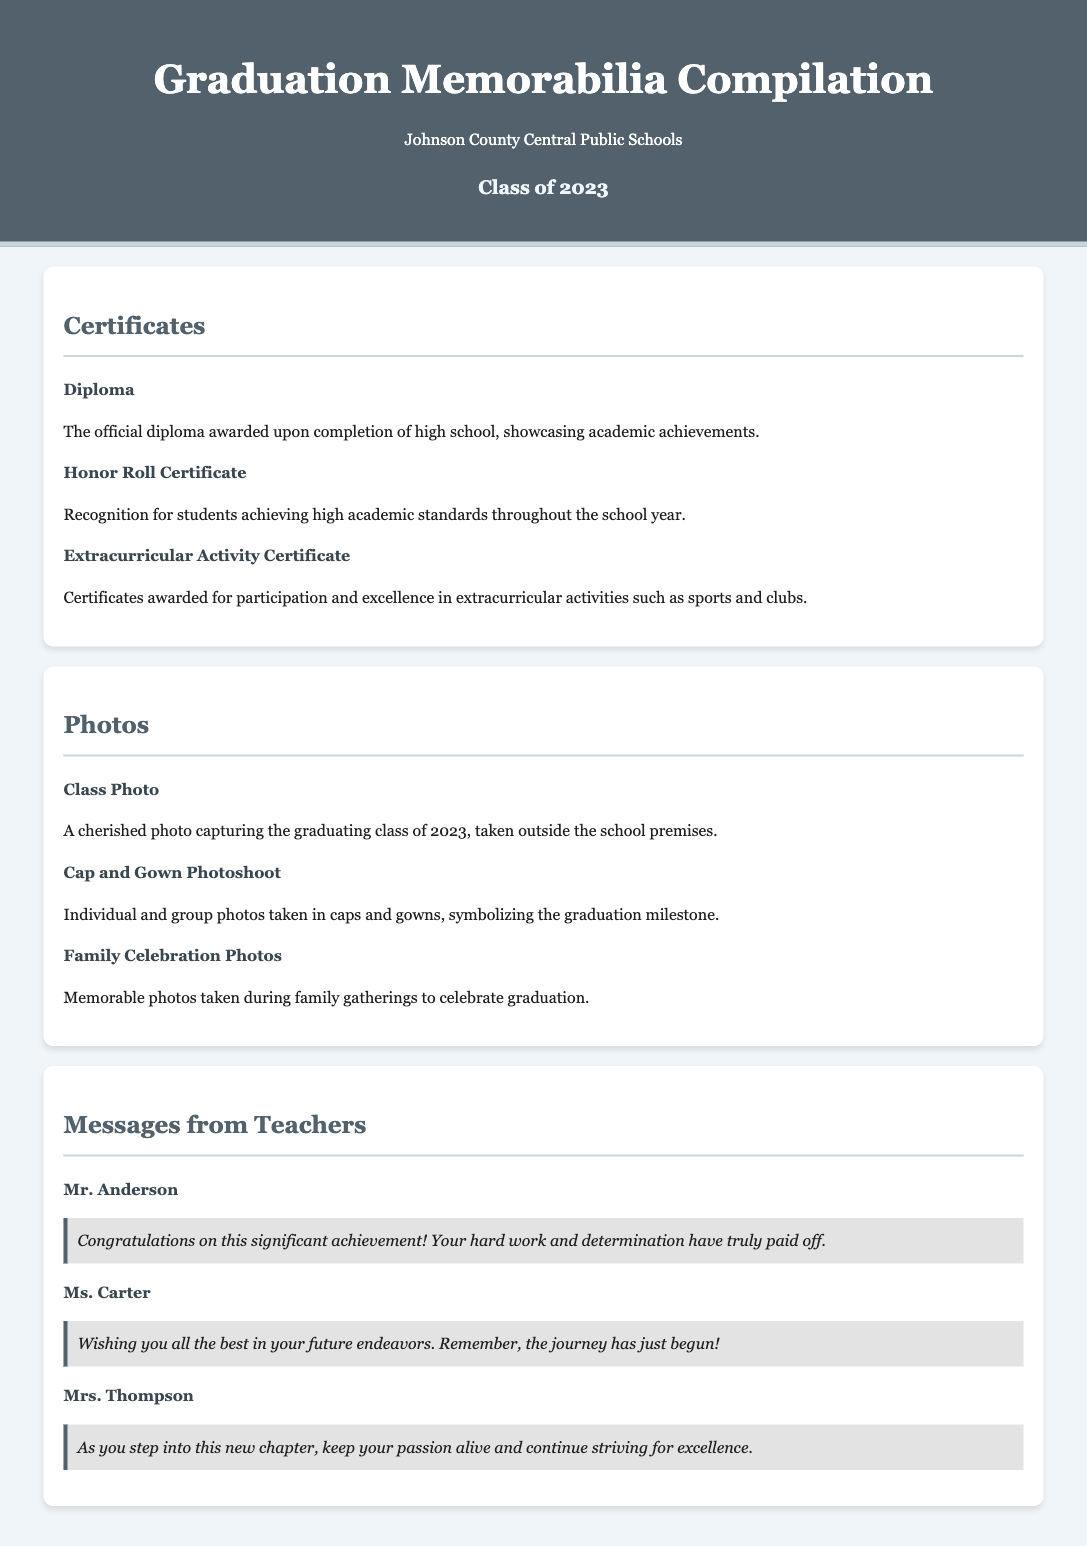What titles are listed under Certificates? The document lists three titles under Certificates: Diploma, Honor Roll Certificate, and Extracurricular Activity Certificate.
Answer: Diploma, Honor Roll Certificate, Extracurricular Activity Certificate Who is the teacher that congratulated the students? Mr. Anderson is mentioned as sending congratulations to the students for their achievement.
Answer: Mr. Anderson What event is represented by the Class Photo? The Class Photo represents a significant milestone capturing the graduating class.
Answer: Graduation How many types of photos are included in the photos section? There are three types of photos mentioned in the photos section.
Answer: Three What message did Ms. Carter provide to the students? Ms. Carter wished the students all the best in their future endeavors and reminded them that the journey has just begun.
Answer: All the best in your future endeavors What is the overall theme of the document? The overall theme of the document is a compilation of graduation memorabilia for the Class of 2023.
Answer: Graduation memorabilia 